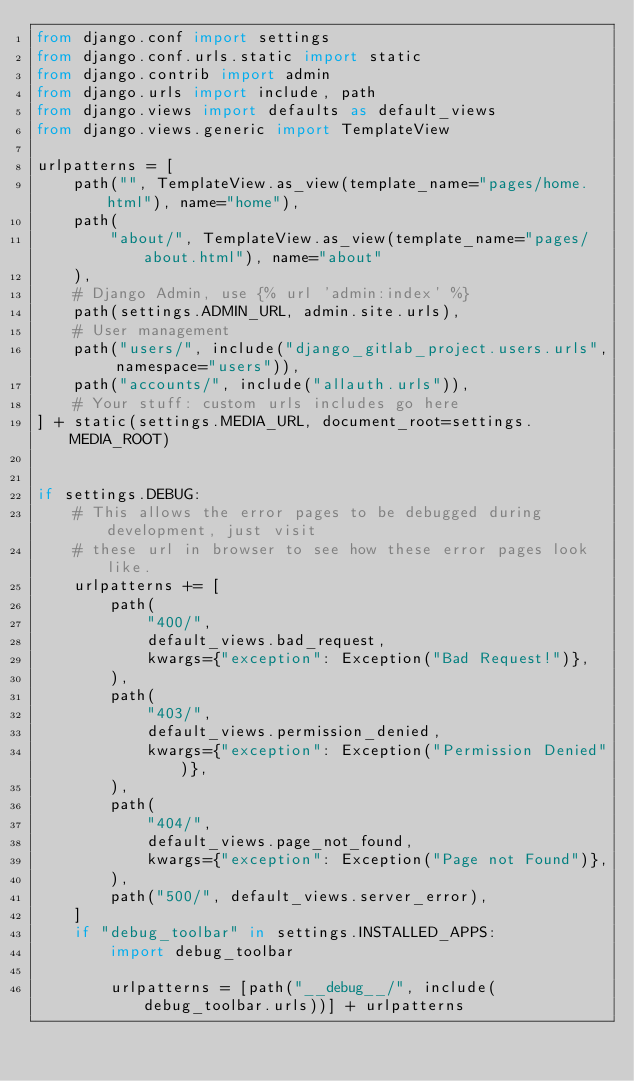<code> <loc_0><loc_0><loc_500><loc_500><_Python_>from django.conf import settings
from django.conf.urls.static import static
from django.contrib import admin
from django.urls import include, path
from django.views import defaults as default_views
from django.views.generic import TemplateView

urlpatterns = [
    path("", TemplateView.as_view(template_name="pages/home.html"), name="home"),
    path(
        "about/", TemplateView.as_view(template_name="pages/about.html"), name="about"
    ),
    # Django Admin, use {% url 'admin:index' %}
    path(settings.ADMIN_URL, admin.site.urls),
    # User management
    path("users/", include("django_gitlab_project.users.urls", namespace="users")),
    path("accounts/", include("allauth.urls")),
    # Your stuff: custom urls includes go here
] + static(settings.MEDIA_URL, document_root=settings.MEDIA_ROOT)


if settings.DEBUG:
    # This allows the error pages to be debugged during development, just visit
    # these url in browser to see how these error pages look like.
    urlpatterns += [
        path(
            "400/",
            default_views.bad_request,
            kwargs={"exception": Exception("Bad Request!")},
        ),
        path(
            "403/",
            default_views.permission_denied,
            kwargs={"exception": Exception("Permission Denied")},
        ),
        path(
            "404/",
            default_views.page_not_found,
            kwargs={"exception": Exception("Page not Found")},
        ),
        path("500/", default_views.server_error),
    ]
    if "debug_toolbar" in settings.INSTALLED_APPS:
        import debug_toolbar

        urlpatterns = [path("__debug__/", include(debug_toolbar.urls))] + urlpatterns
</code> 